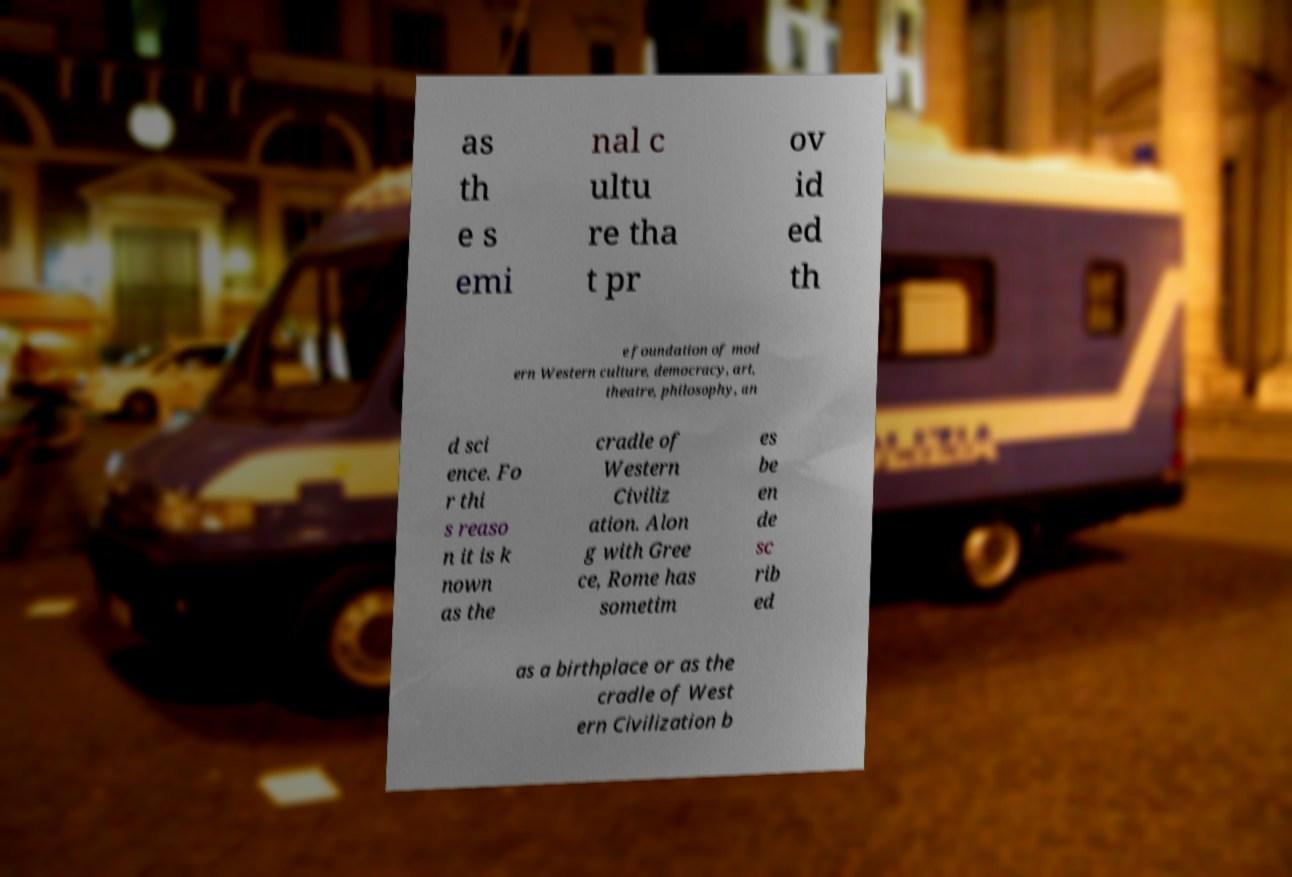Could you assist in decoding the text presented in this image and type it out clearly? as th e s emi nal c ultu re tha t pr ov id ed th e foundation of mod ern Western culture, democracy, art, theatre, philosophy, an d sci ence. Fo r thi s reaso n it is k nown as the cradle of Western Civiliz ation. Alon g with Gree ce, Rome has sometim es be en de sc rib ed as a birthplace or as the cradle of West ern Civilization b 